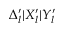Convert formula to latex. <formula><loc_0><loc_0><loc_500><loc_500>\Delta _ { l } ^ { \prime } | X _ { l } ^ { \prime } | Y _ { l } ^ { \prime }</formula> 